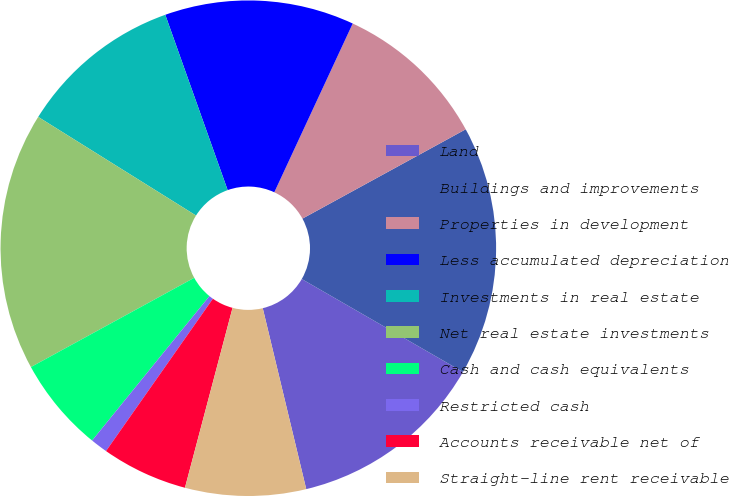<chart> <loc_0><loc_0><loc_500><loc_500><pie_chart><fcel>Land<fcel>Buildings and improvements<fcel>Properties in development<fcel>Less accumulated depreciation<fcel>Investments in real estate<fcel>Net real estate investments<fcel>Cash and cash equivalents<fcel>Restricted cash<fcel>Accounts receivable net of<fcel>Straight-line rent receivable<nl><fcel>12.92%<fcel>16.29%<fcel>10.11%<fcel>12.36%<fcel>10.67%<fcel>16.85%<fcel>6.18%<fcel>1.12%<fcel>5.62%<fcel>7.87%<nl></chart> 